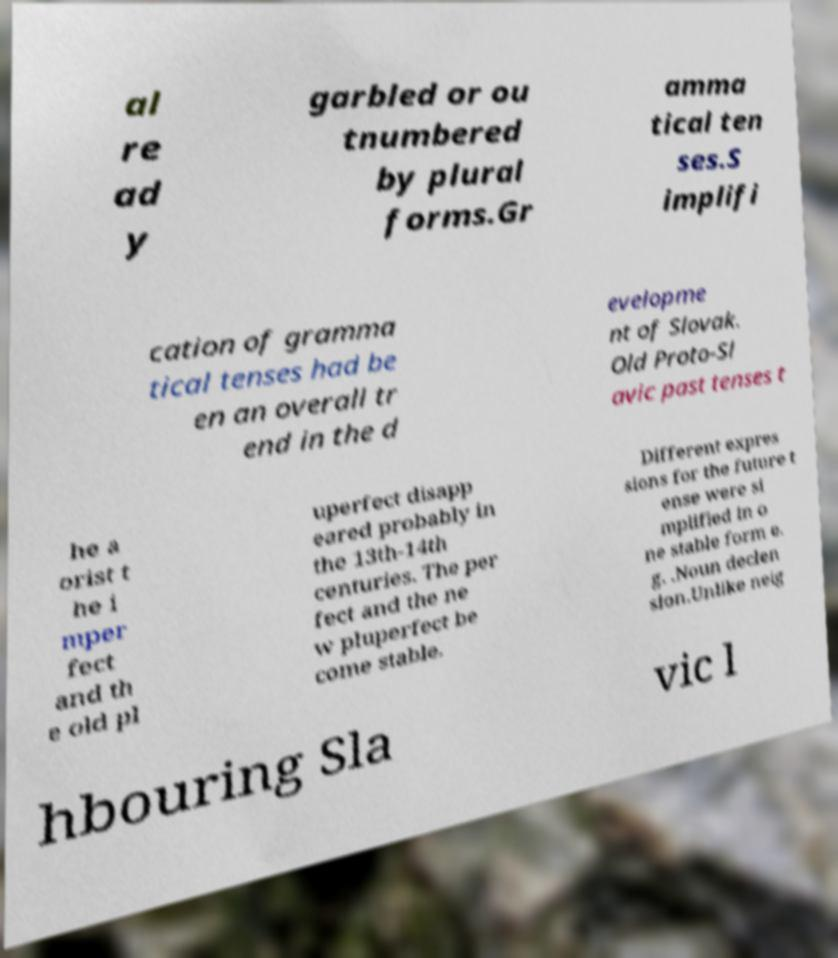I need the written content from this picture converted into text. Can you do that? al re ad y garbled or ou tnumbered by plural forms.Gr amma tical ten ses.S implifi cation of gramma tical tenses had be en an overall tr end in the d evelopme nt of Slovak. Old Proto-Sl avic past tenses t he a orist t he i mper fect and th e old pl uperfect disapp eared probably in the 13th-14th centuries. The per fect and the ne w pluperfect be come stable. Different expres sions for the future t ense were si mplified in o ne stable form e. g. .Noun declen sion.Unlike neig hbouring Sla vic l 